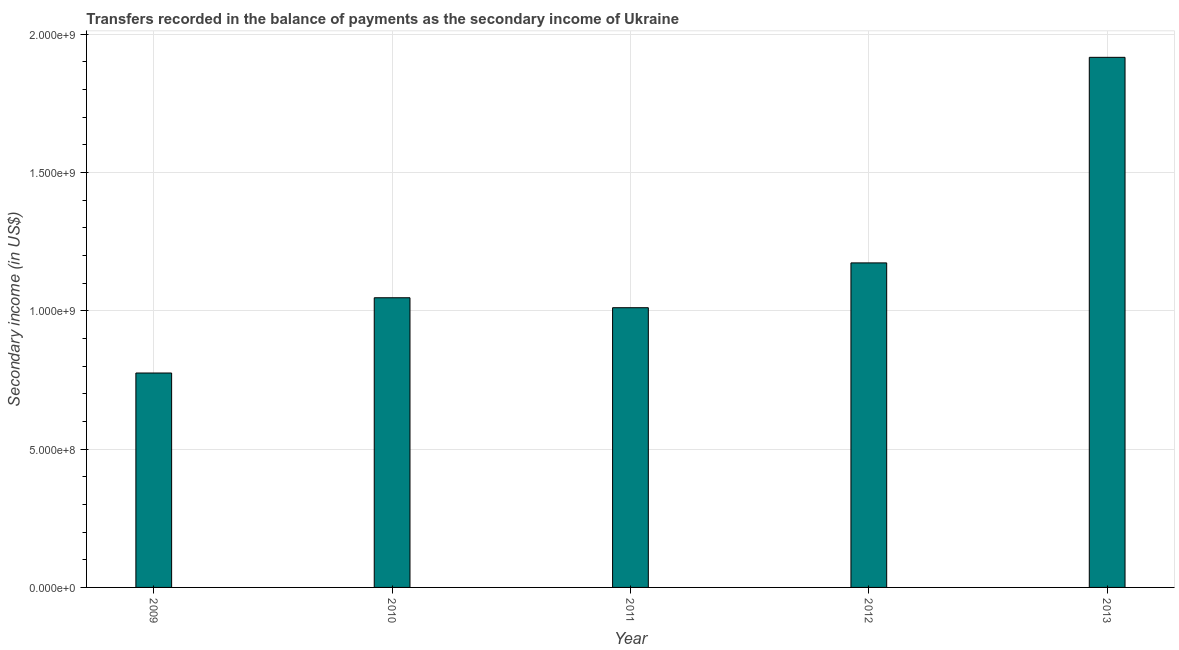Does the graph contain any zero values?
Provide a succinct answer. No. What is the title of the graph?
Offer a very short reply. Transfers recorded in the balance of payments as the secondary income of Ukraine. What is the label or title of the Y-axis?
Ensure brevity in your answer.  Secondary income (in US$). What is the amount of secondary income in 2013?
Your answer should be very brief. 1.92e+09. Across all years, what is the maximum amount of secondary income?
Give a very brief answer. 1.92e+09. Across all years, what is the minimum amount of secondary income?
Your answer should be compact. 7.75e+08. What is the sum of the amount of secondary income?
Ensure brevity in your answer.  5.92e+09. What is the difference between the amount of secondary income in 2009 and 2011?
Ensure brevity in your answer.  -2.36e+08. What is the average amount of secondary income per year?
Offer a very short reply. 1.18e+09. What is the median amount of secondary income?
Your answer should be very brief. 1.05e+09. Do a majority of the years between 2011 and 2010 (inclusive) have amount of secondary income greater than 1600000000 US$?
Offer a terse response. No. What is the ratio of the amount of secondary income in 2009 to that in 2012?
Ensure brevity in your answer.  0.66. Is the amount of secondary income in 2009 less than that in 2012?
Offer a terse response. Yes. Is the difference between the amount of secondary income in 2011 and 2012 greater than the difference between any two years?
Offer a very short reply. No. What is the difference between the highest and the second highest amount of secondary income?
Give a very brief answer. 7.43e+08. Is the sum of the amount of secondary income in 2009 and 2013 greater than the maximum amount of secondary income across all years?
Your answer should be compact. Yes. What is the difference between the highest and the lowest amount of secondary income?
Your answer should be very brief. 1.14e+09. How many bars are there?
Your answer should be compact. 5. Are all the bars in the graph horizontal?
Offer a very short reply. No. Are the values on the major ticks of Y-axis written in scientific E-notation?
Make the answer very short. Yes. What is the Secondary income (in US$) of 2009?
Keep it short and to the point. 7.75e+08. What is the Secondary income (in US$) in 2010?
Give a very brief answer. 1.05e+09. What is the Secondary income (in US$) in 2011?
Offer a terse response. 1.01e+09. What is the Secondary income (in US$) in 2012?
Offer a terse response. 1.17e+09. What is the Secondary income (in US$) in 2013?
Offer a very short reply. 1.92e+09. What is the difference between the Secondary income (in US$) in 2009 and 2010?
Offer a very short reply. -2.72e+08. What is the difference between the Secondary income (in US$) in 2009 and 2011?
Provide a succinct answer. -2.36e+08. What is the difference between the Secondary income (in US$) in 2009 and 2012?
Your answer should be compact. -3.98e+08. What is the difference between the Secondary income (in US$) in 2009 and 2013?
Provide a succinct answer. -1.14e+09. What is the difference between the Secondary income (in US$) in 2010 and 2011?
Your response must be concise. 3.60e+07. What is the difference between the Secondary income (in US$) in 2010 and 2012?
Offer a very short reply. -1.26e+08. What is the difference between the Secondary income (in US$) in 2010 and 2013?
Your answer should be compact. -8.69e+08. What is the difference between the Secondary income (in US$) in 2011 and 2012?
Ensure brevity in your answer.  -1.62e+08. What is the difference between the Secondary income (in US$) in 2011 and 2013?
Provide a succinct answer. -9.05e+08. What is the difference between the Secondary income (in US$) in 2012 and 2013?
Your answer should be very brief. -7.43e+08. What is the ratio of the Secondary income (in US$) in 2009 to that in 2010?
Offer a terse response. 0.74. What is the ratio of the Secondary income (in US$) in 2009 to that in 2011?
Your answer should be compact. 0.77. What is the ratio of the Secondary income (in US$) in 2009 to that in 2012?
Keep it short and to the point. 0.66. What is the ratio of the Secondary income (in US$) in 2009 to that in 2013?
Give a very brief answer. 0.4. What is the ratio of the Secondary income (in US$) in 2010 to that in 2011?
Give a very brief answer. 1.04. What is the ratio of the Secondary income (in US$) in 2010 to that in 2012?
Keep it short and to the point. 0.89. What is the ratio of the Secondary income (in US$) in 2010 to that in 2013?
Keep it short and to the point. 0.55. What is the ratio of the Secondary income (in US$) in 2011 to that in 2012?
Offer a very short reply. 0.86. What is the ratio of the Secondary income (in US$) in 2011 to that in 2013?
Your response must be concise. 0.53. What is the ratio of the Secondary income (in US$) in 2012 to that in 2013?
Your answer should be compact. 0.61. 